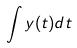Convert formula to latex. <formula><loc_0><loc_0><loc_500><loc_500>\int y ( t ) d t</formula> 